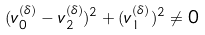<formula> <loc_0><loc_0><loc_500><loc_500>( v ^ { ( \delta ) } _ { 0 } - v ^ { ( \delta ) } _ { 2 } ) ^ { 2 } + ( v ^ { ( \delta ) } _ { 1 } ) ^ { 2 } \ne 0</formula> 